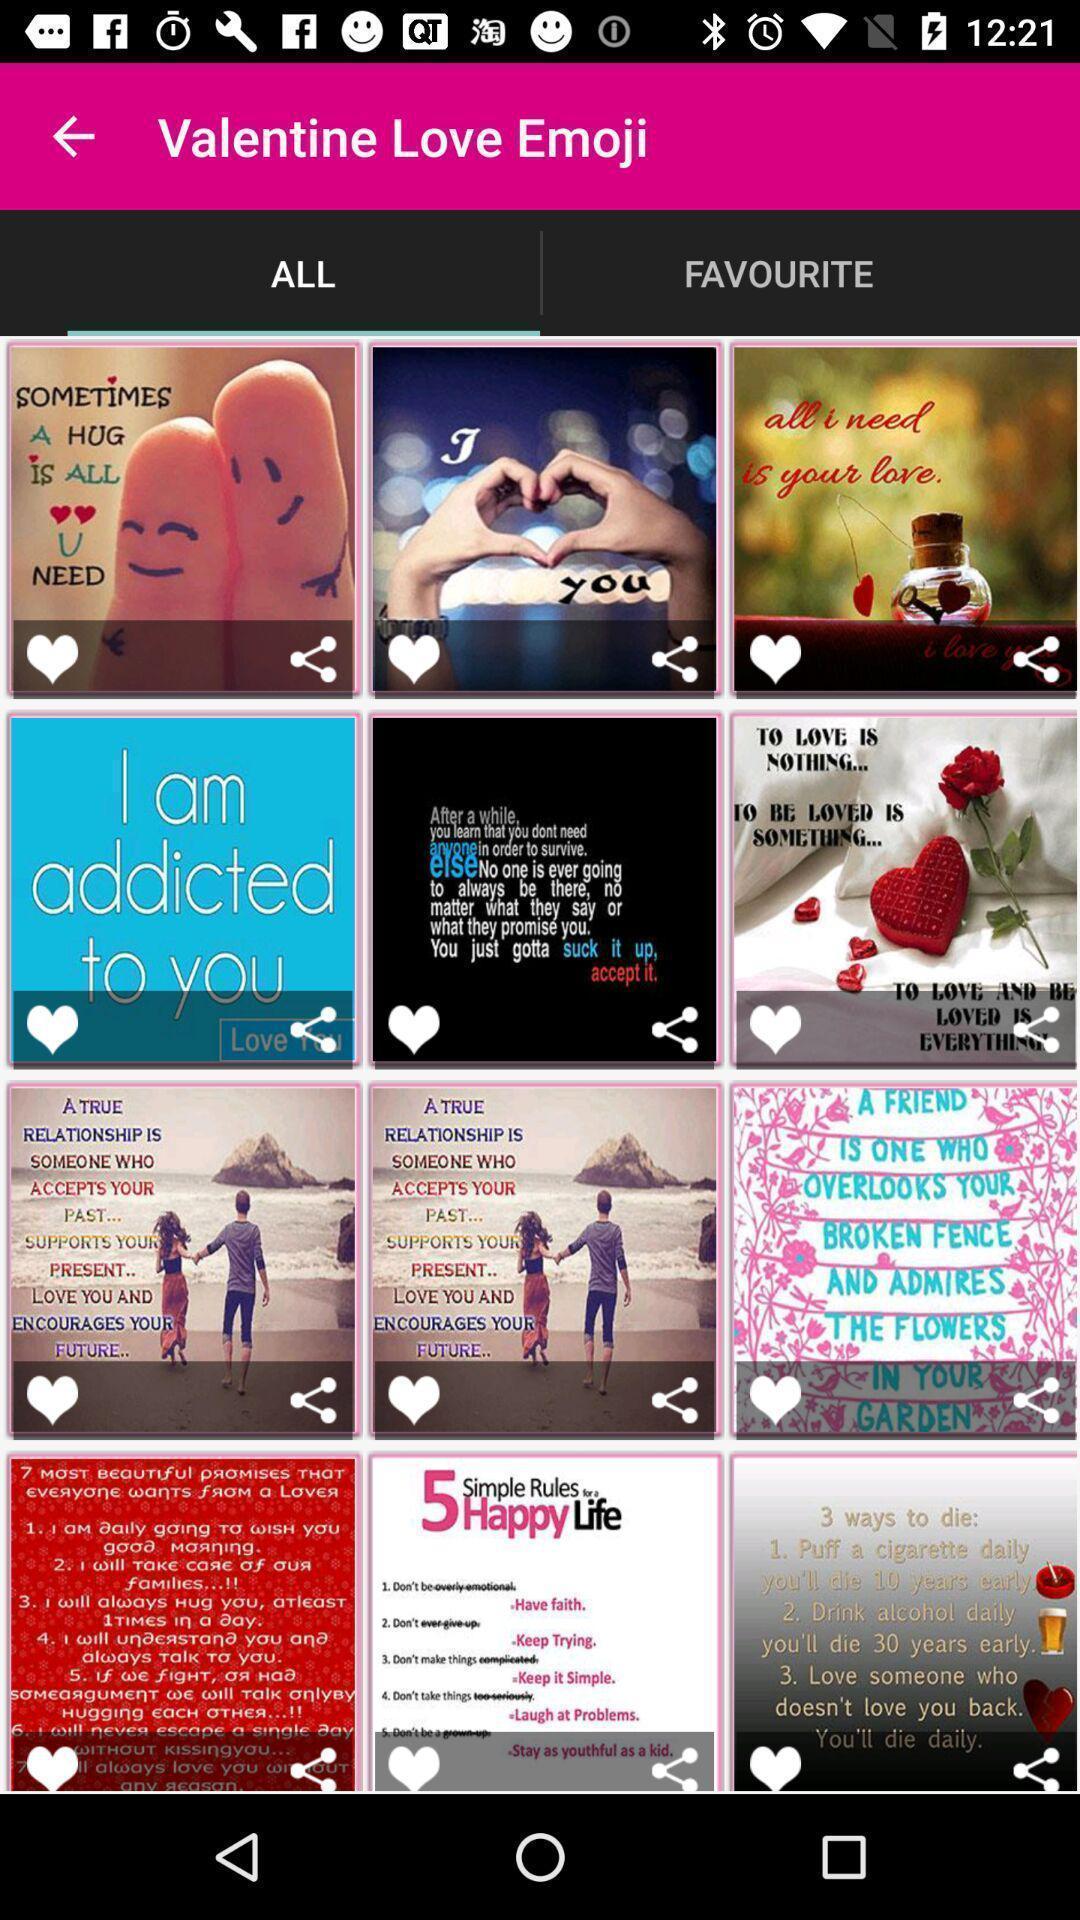Summarize the main components in this picture. Screen showing list of various emojis in social app. 